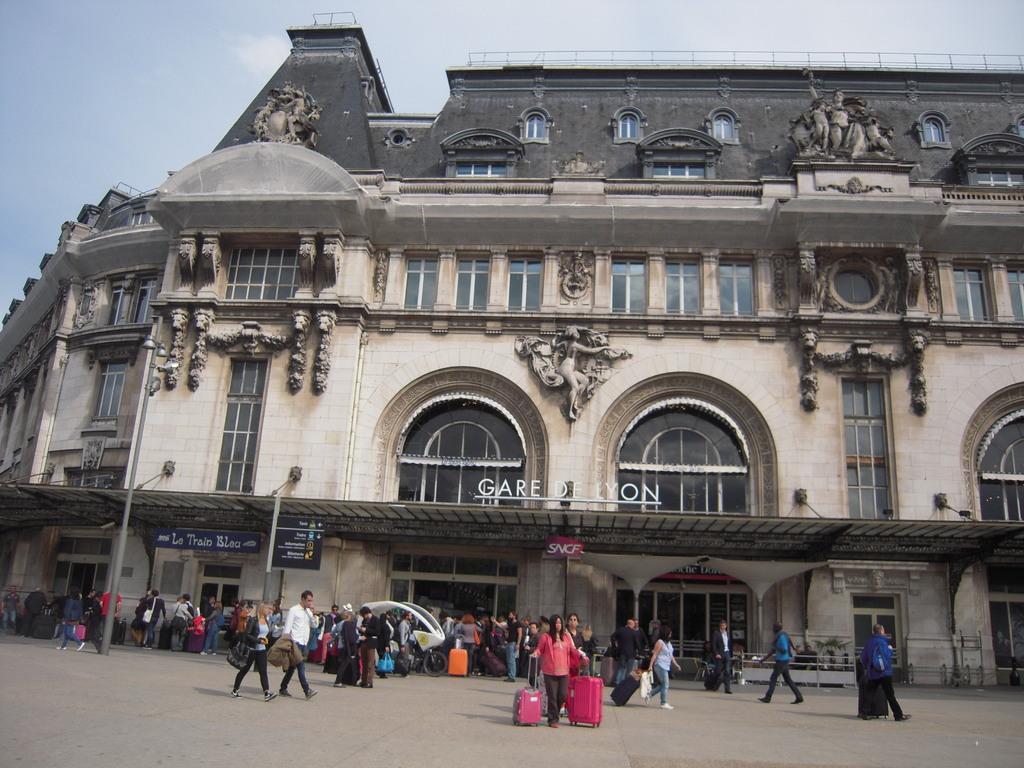Can you describe this image briefly? In the image there are many people walking on the road and behind them there is a building with many windows and doors and above its sky. 